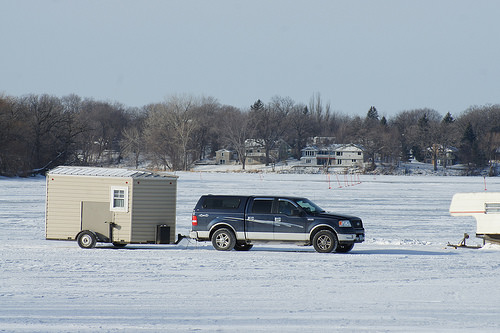<image>
Can you confirm if the car is behind the tree? No. The car is not behind the tree. From this viewpoint, the car appears to be positioned elsewhere in the scene. 